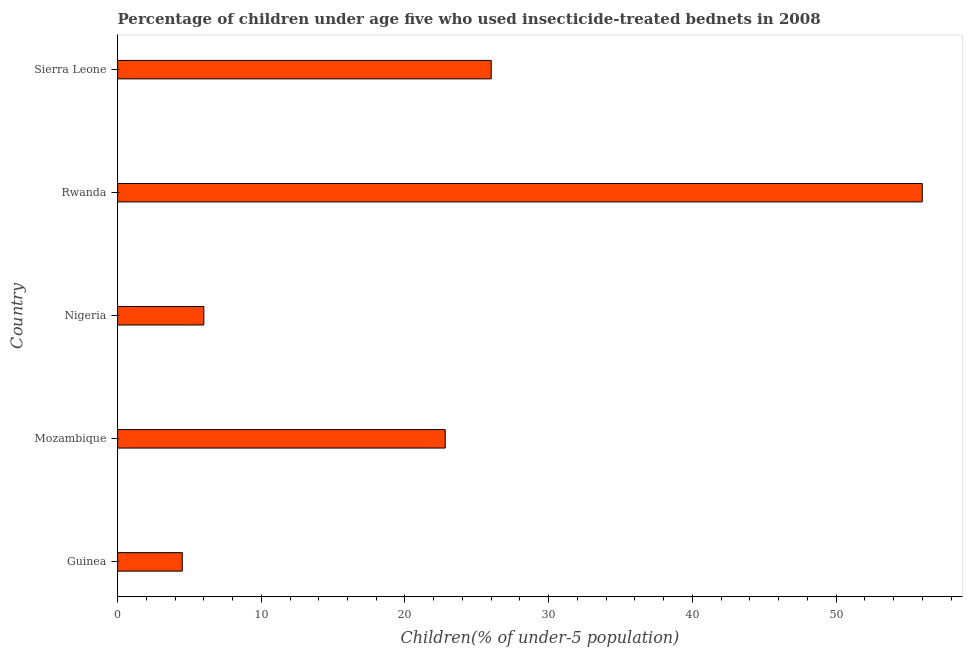Does the graph contain grids?
Make the answer very short. No. What is the title of the graph?
Ensure brevity in your answer.  Percentage of children under age five who used insecticide-treated bednets in 2008. What is the label or title of the X-axis?
Give a very brief answer. Children(% of under-5 population). What is the label or title of the Y-axis?
Your response must be concise. Country. Across all countries, what is the maximum percentage of children who use of insecticide-treated bed nets?
Give a very brief answer. 56. Across all countries, what is the minimum percentage of children who use of insecticide-treated bed nets?
Ensure brevity in your answer.  4.5. In which country was the percentage of children who use of insecticide-treated bed nets maximum?
Your answer should be compact. Rwanda. In which country was the percentage of children who use of insecticide-treated bed nets minimum?
Your answer should be very brief. Guinea. What is the sum of the percentage of children who use of insecticide-treated bed nets?
Keep it short and to the point. 115.3. What is the difference between the percentage of children who use of insecticide-treated bed nets in Guinea and Nigeria?
Provide a succinct answer. -1.5. What is the average percentage of children who use of insecticide-treated bed nets per country?
Ensure brevity in your answer.  23.06. What is the median percentage of children who use of insecticide-treated bed nets?
Provide a succinct answer. 22.8. What is the ratio of the percentage of children who use of insecticide-treated bed nets in Rwanda to that in Sierra Leone?
Offer a very short reply. 2.15. Is the difference between the percentage of children who use of insecticide-treated bed nets in Guinea and Rwanda greater than the difference between any two countries?
Make the answer very short. Yes. What is the difference between the highest and the lowest percentage of children who use of insecticide-treated bed nets?
Give a very brief answer. 51.5. How many countries are there in the graph?
Your answer should be compact. 5. What is the difference between two consecutive major ticks on the X-axis?
Your answer should be compact. 10. What is the Children(% of under-5 population) in Guinea?
Offer a terse response. 4.5. What is the Children(% of under-5 population) of Mozambique?
Offer a very short reply. 22.8. What is the difference between the Children(% of under-5 population) in Guinea and Mozambique?
Your response must be concise. -18.3. What is the difference between the Children(% of under-5 population) in Guinea and Nigeria?
Your answer should be compact. -1.5. What is the difference between the Children(% of under-5 population) in Guinea and Rwanda?
Offer a very short reply. -51.5. What is the difference between the Children(% of under-5 population) in Guinea and Sierra Leone?
Your answer should be very brief. -21.5. What is the difference between the Children(% of under-5 population) in Mozambique and Rwanda?
Give a very brief answer. -33.2. What is the difference between the Children(% of under-5 population) in Mozambique and Sierra Leone?
Keep it short and to the point. -3.2. What is the difference between the Children(% of under-5 population) in Nigeria and Rwanda?
Give a very brief answer. -50. What is the difference between the Children(% of under-5 population) in Rwanda and Sierra Leone?
Offer a terse response. 30. What is the ratio of the Children(% of under-5 population) in Guinea to that in Mozambique?
Provide a short and direct response. 0.2. What is the ratio of the Children(% of under-5 population) in Guinea to that in Nigeria?
Give a very brief answer. 0.75. What is the ratio of the Children(% of under-5 population) in Guinea to that in Sierra Leone?
Provide a short and direct response. 0.17. What is the ratio of the Children(% of under-5 population) in Mozambique to that in Nigeria?
Offer a very short reply. 3.8. What is the ratio of the Children(% of under-5 population) in Mozambique to that in Rwanda?
Offer a terse response. 0.41. What is the ratio of the Children(% of under-5 population) in Mozambique to that in Sierra Leone?
Your answer should be compact. 0.88. What is the ratio of the Children(% of under-5 population) in Nigeria to that in Rwanda?
Provide a succinct answer. 0.11. What is the ratio of the Children(% of under-5 population) in Nigeria to that in Sierra Leone?
Keep it short and to the point. 0.23. What is the ratio of the Children(% of under-5 population) in Rwanda to that in Sierra Leone?
Provide a short and direct response. 2.15. 